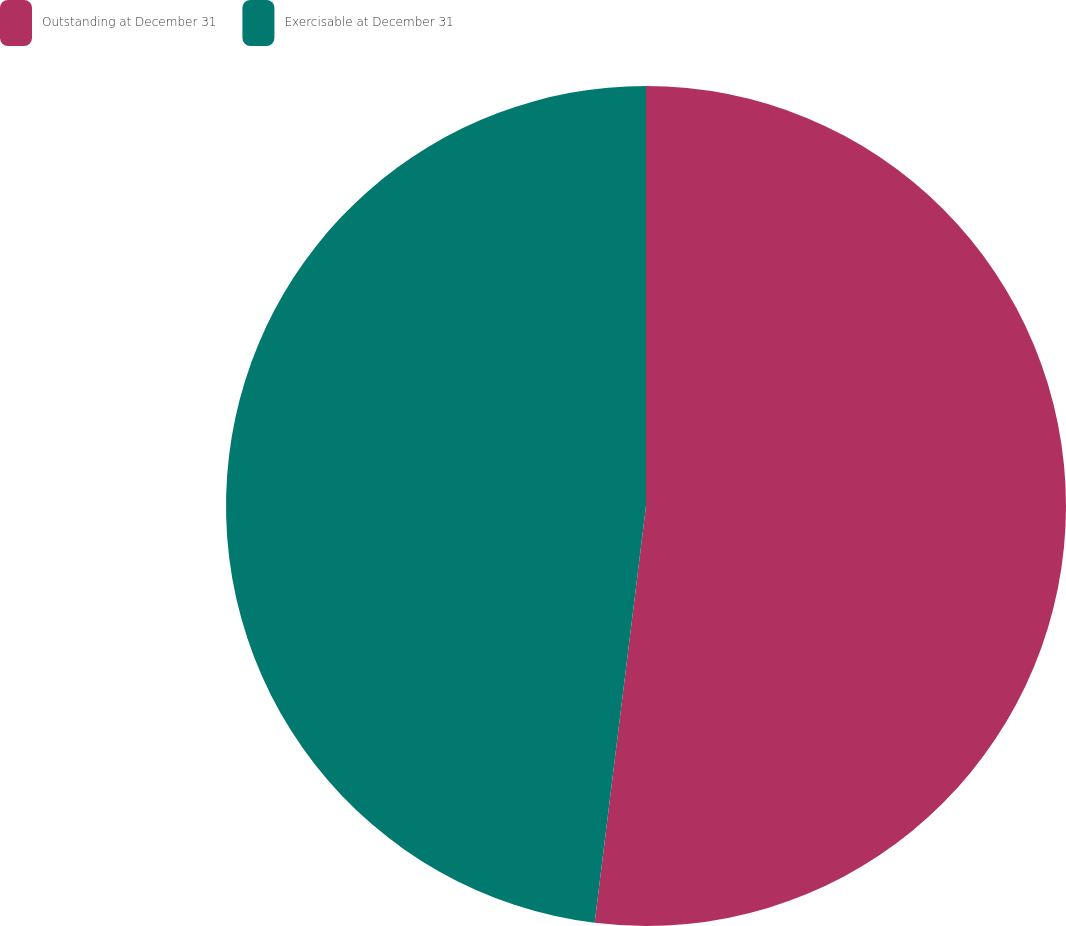<chart> <loc_0><loc_0><loc_500><loc_500><pie_chart><fcel>Outstanding at December 31<fcel>Exercisable at December 31<nl><fcel>51.95%<fcel>48.05%<nl></chart> 